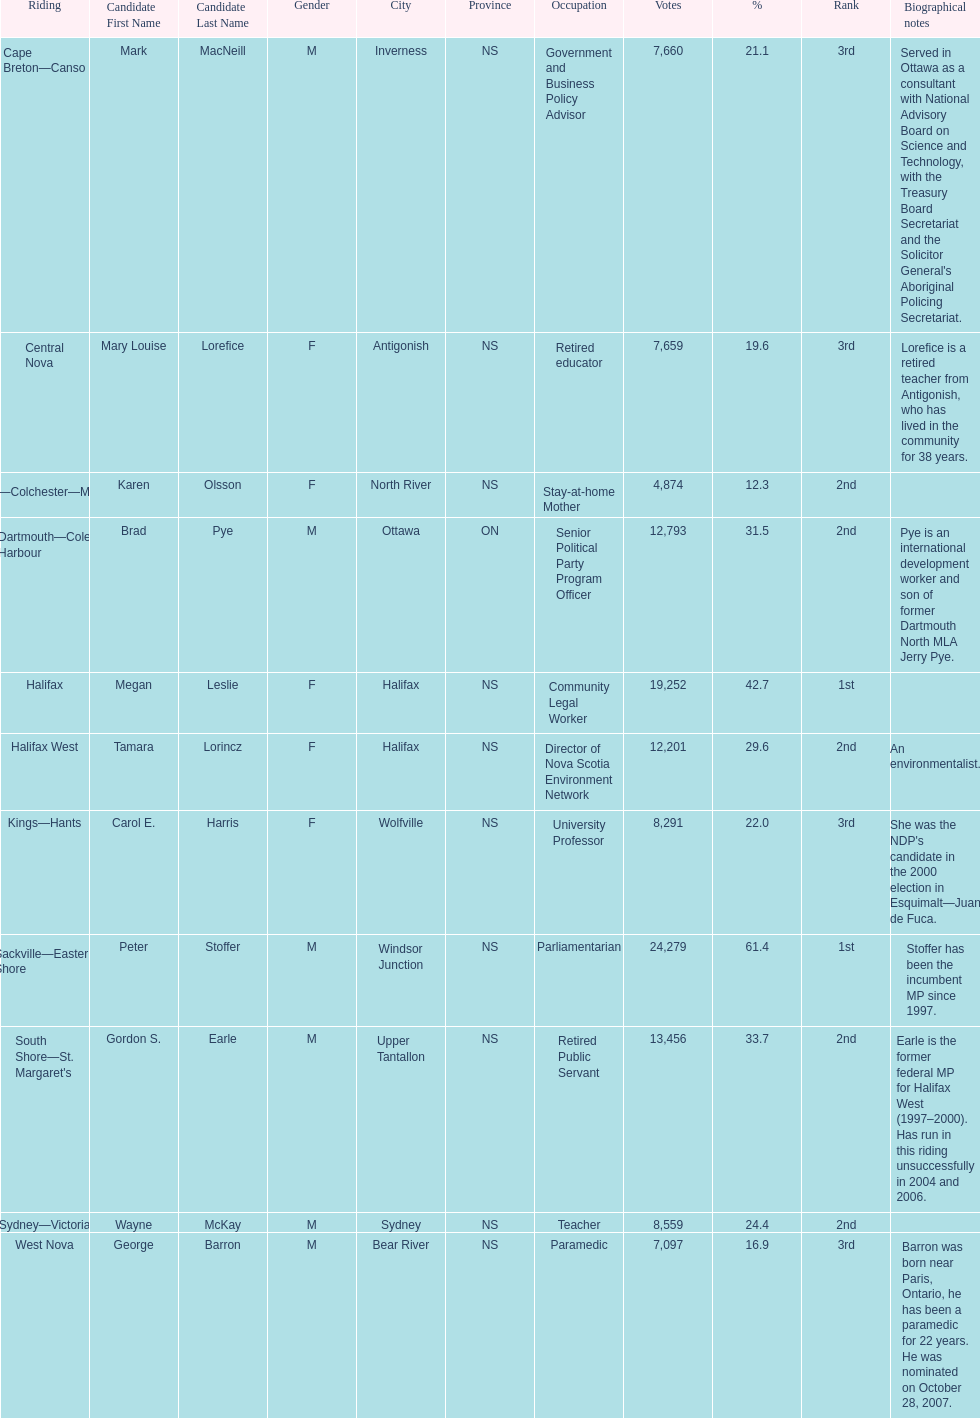Tell me the total number of votes the female candidates got. 52,277. Would you mind parsing the complete table? {'header': ['Riding', 'Candidate First Name', 'Candidate Last Name', 'Gender', 'City', 'Province', 'Occupation', 'Votes', '%', 'Rank', 'Biographical notes'], 'rows': [['Cape Breton—Canso', 'Mark', 'MacNeill', 'M', 'Inverness', 'NS', 'Government and Business Policy Advisor', '7,660', '21.1', '3rd', "Served in Ottawa as a consultant with National Advisory Board on Science and Technology, with the Treasury Board Secretariat and the Solicitor General's Aboriginal Policing Secretariat."], ['Central Nova', 'Mary Louise', 'Lorefice', 'F', 'Antigonish', 'NS', 'Retired educator', '7,659', '19.6', '3rd', 'Lorefice is a retired teacher from Antigonish, who has lived in the community for 38 years.'], ['Cumberland—Colchester—Musquodoboit Valley', 'Karen', 'Olsson', 'F', 'North River', 'NS', 'Stay-at-home Mother', '4,874', '12.3', '2nd', ''], ['Dartmouth—Cole Harbour', 'Brad', 'Pye', 'M', 'Ottawa', 'ON', 'Senior Political Party Program Officer', '12,793', '31.5', '2nd', 'Pye is an international development worker and son of former Dartmouth North MLA Jerry Pye.'], ['Halifax', 'Megan', 'Leslie', 'F', 'Halifax', 'NS', 'Community Legal Worker', '19,252', '42.7', '1st', ''], ['Halifax West', 'Tamara', 'Lorincz', 'F', 'Halifax', 'NS', 'Director of Nova Scotia Environment Network', '12,201', '29.6', '2nd', 'An environmentalist.'], ['Kings—Hants', 'Carol E.', 'Harris', 'F', 'Wolfville', 'NS', 'University Professor', '8,291', '22.0', '3rd', "She was the NDP's candidate in the 2000 election in Esquimalt—Juan de Fuca."], ['Sackville—Eastern Shore', 'Peter', 'Stoffer', 'M', 'Windsor Junction', 'NS', 'Parliamentarian', '24,279', '61.4', '1st', 'Stoffer has been the incumbent MP since 1997.'], ["South Shore—St. Margaret's", 'Gordon S.', 'Earle', 'M', 'Upper Tantallon', 'NS', 'Retired Public Servant', '13,456', '33.7', '2nd', 'Earle is the former federal MP for Halifax West (1997–2000). Has run in this riding unsuccessfully in 2004 and 2006.'], ['Sydney—Victoria', 'Wayne', 'McKay', 'M', 'Sydney', 'NS', 'Teacher', '8,559', '24.4', '2nd', ''], ['West Nova', 'George', 'Barron', 'M', 'Bear River', 'NS', 'Paramedic', '7,097', '16.9', '3rd', 'Barron was born near Paris, Ontario, he has been a paramedic for 22 years. He was nominated on October 28, 2007.']]} 